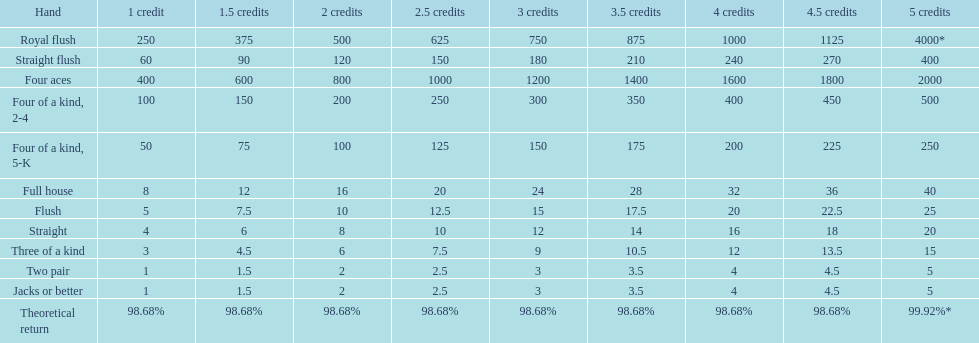At most, what could a person earn for having a full house? 40. 